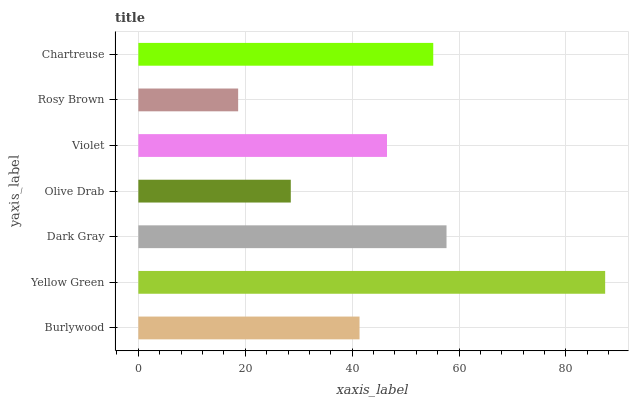Is Rosy Brown the minimum?
Answer yes or no. Yes. Is Yellow Green the maximum?
Answer yes or no. Yes. Is Dark Gray the minimum?
Answer yes or no. No. Is Dark Gray the maximum?
Answer yes or no. No. Is Yellow Green greater than Dark Gray?
Answer yes or no. Yes. Is Dark Gray less than Yellow Green?
Answer yes or no. Yes. Is Dark Gray greater than Yellow Green?
Answer yes or no. No. Is Yellow Green less than Dark Gray?
Answer yes or no. No. Is Violet the high median?
Answer yes or no. Yes. Is Violet the low median?
Answer yes or no. Yes. Is Rosy Brown the high median?
Answer yes or no. No. Is Yellow Green the low median?
Answer yes or no. No. 